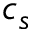<formula> <loc_0><loc_0><loc_500><loc_500>c _ { s }</formula> 